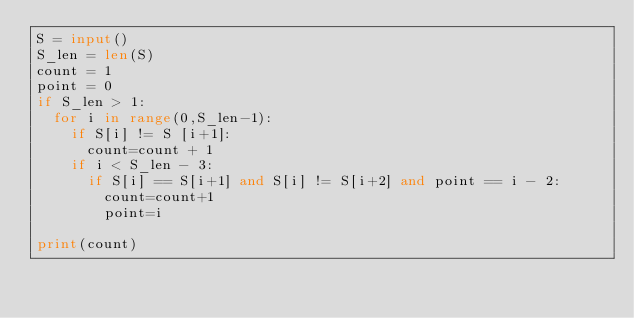Convert code to text. <code><loc_0><loc_0><loc_500><loc_500><_Python_>S = input()
S_len = len(S)
count = 1
point = 0
if S_len > 1:
  for i in range(0,S_len-1):
    if S[i] != S [i+1]:
      count=count + 1
    if i < S_len - 3:
      if S[i] == S[i+1] and S[i] != S[i+2] and point == i - 2:
        count=count+1
        point=i

print(count)

</code> 